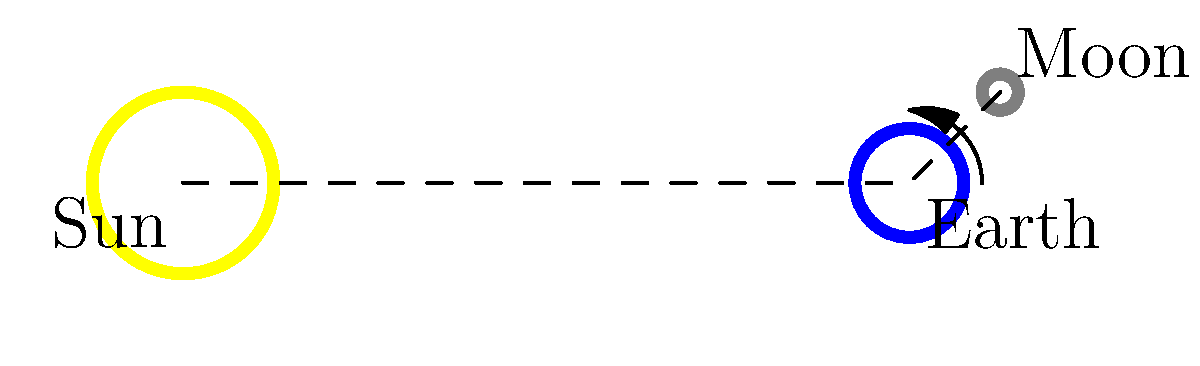In the diagram, the Sun, Earth, and Moon are represented (not to scale). Given the current position of the Moon relative to Earth and the Sun, which phase of the Moon would be observed from Earth? How would you determine this programmatically without relying on reflection? To determine the Moon's phase programmatically without using reflection, we can follow these steps:

1. Define a `MoonPhase` enum or similar structure to represent the possible phases.

2. Calculate the angle between the Earth-Sun line and the Earth-Moon line:
   - Use vector operations to find the direction vectors from Earth to Sun and Earth to Moon.
   - Calculate the dot product of these vectors.
   - Use the arccosine function to find the angle.

3. Determine the side of the Earth-Sun line the Moon is on:
   - Calculate the cross product of Earth-Sun and Earth-Moon vectors.
   - The sign of the z-component indicates which side the Moon is on.

4. Map the calculated angle and side information to the appropriate moon phase:
   - 0° : New Moon
   - 0°-90° (right side) : Waxing Crescent
   - 90° : First Quarter
   - 90°-180° (right side) : Waxing Gibbous
   - 180° : Full Moon
   - 180°-90° (left side) : Waning Gibbous
   - 90° (left side) : Last Quarter
   - 90°-0° (left side) : Waning Crescent

In the given diagram, the Moon is slightly past the 90° angle from the Earth-Sun line on the right side. This corresponds to the Waxing Gibbous phase.

By implementing this logic in a decoupled manner, possibly using a strategy pattern or dependency injection, we can avoid reflection and maintain a flexible, testable design.
Answer: Waxing Gibbous 